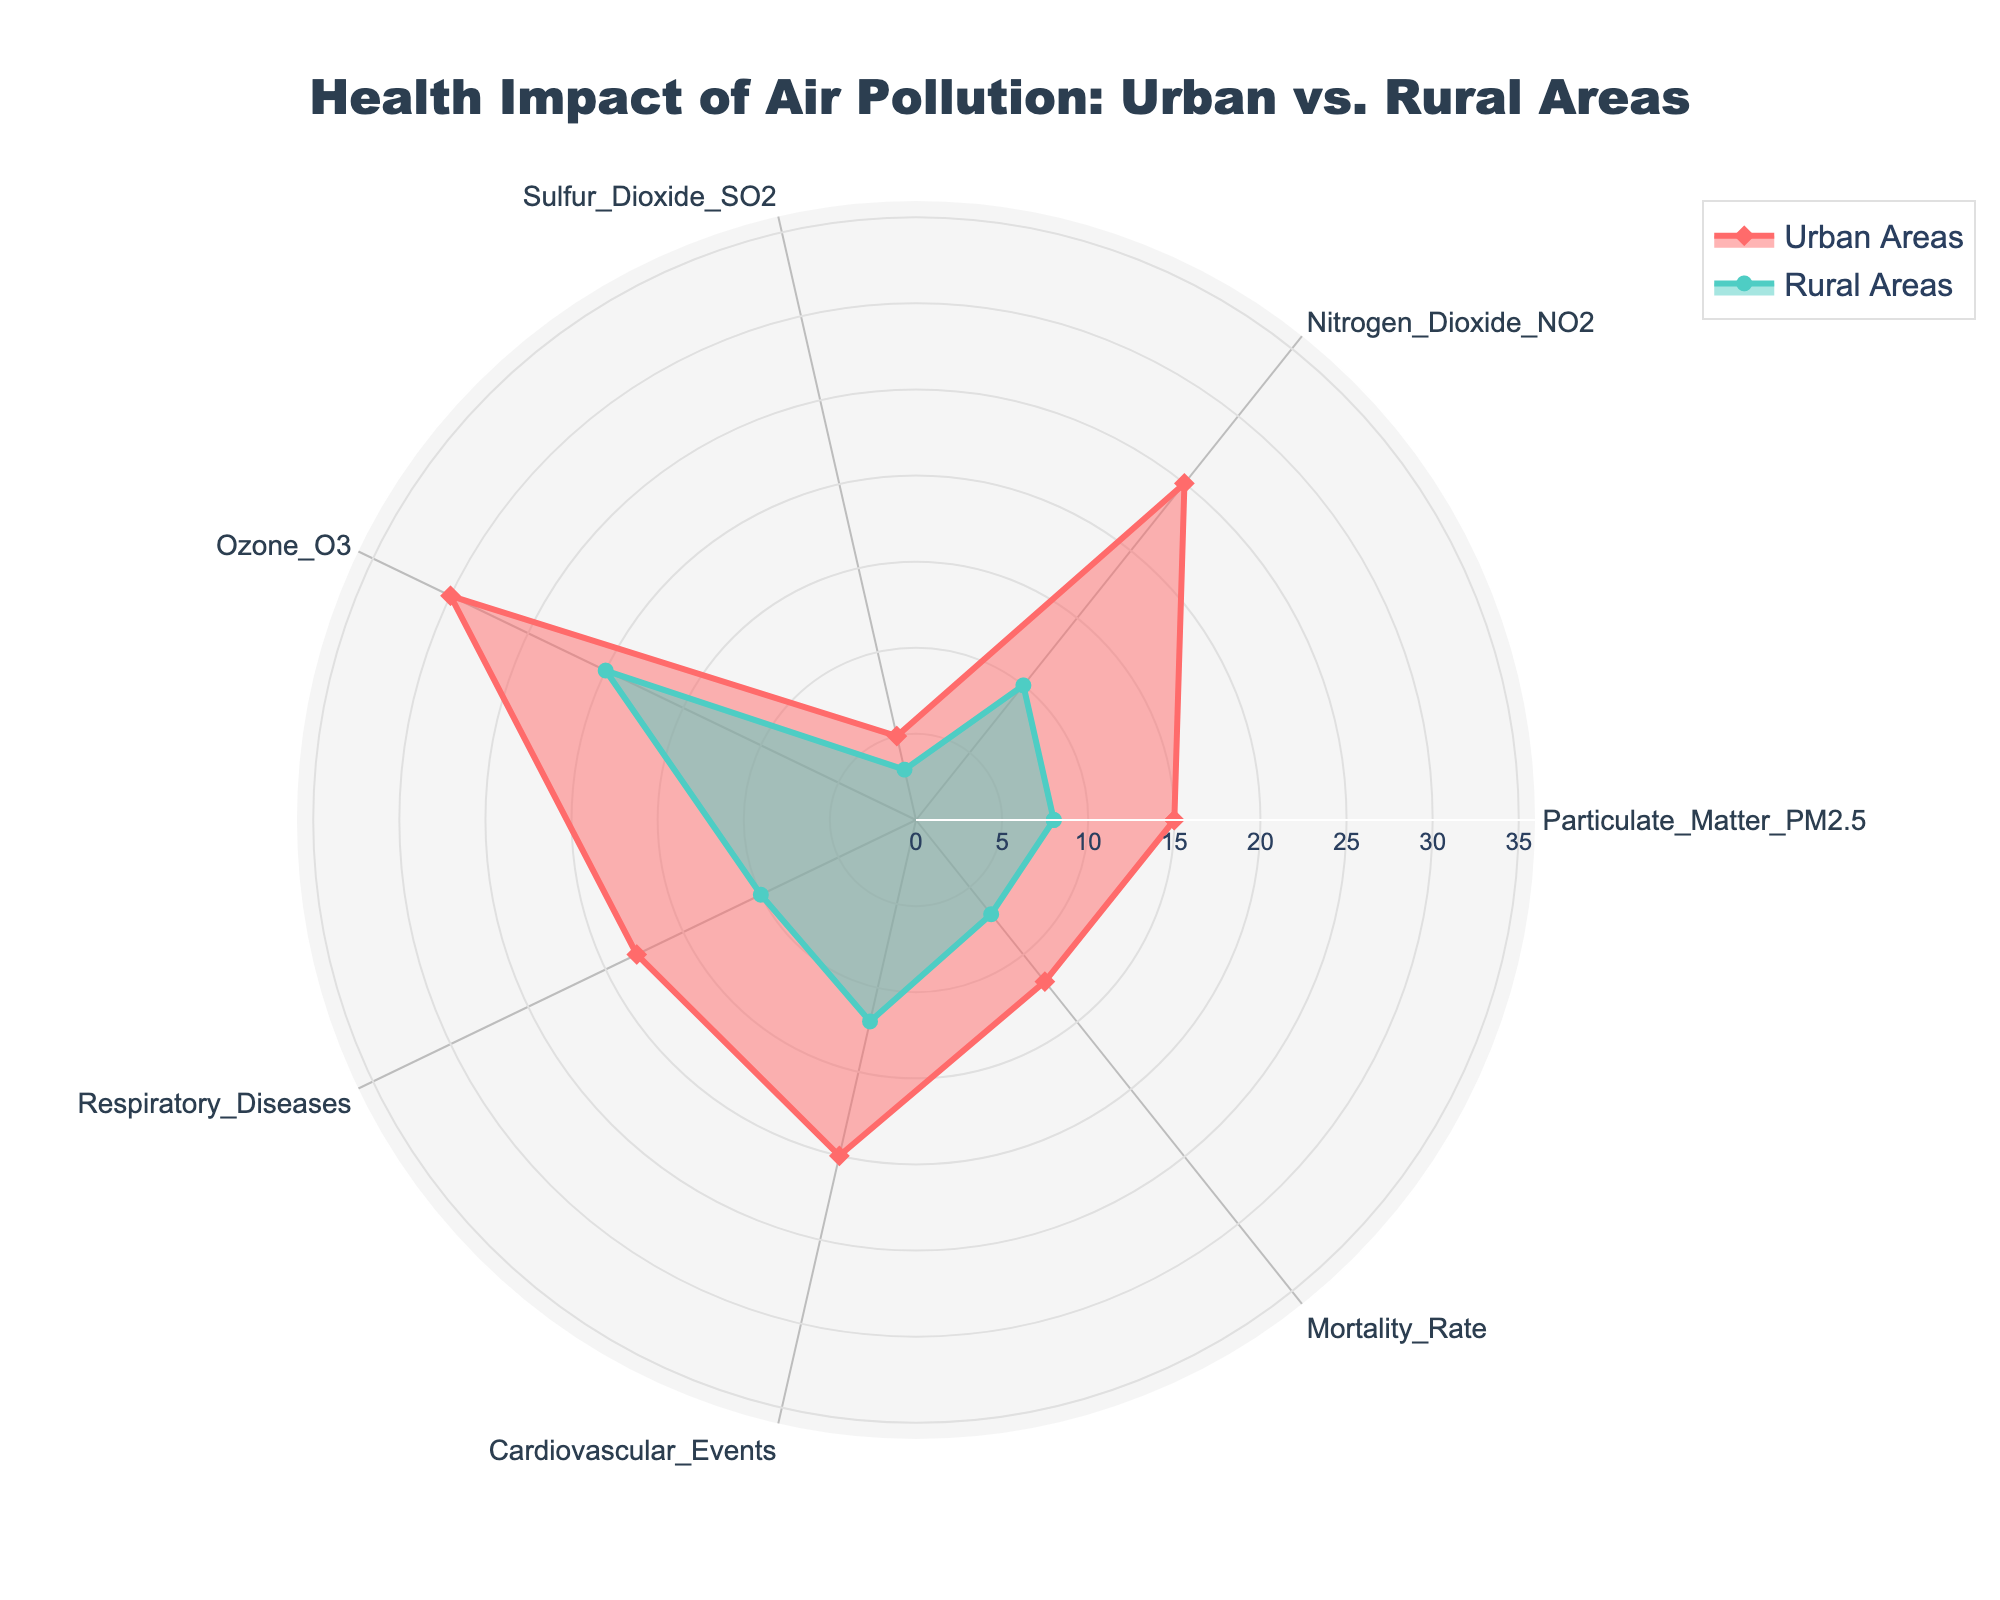What is the title of the radar chart? The title is centrally positioned at the top and is meant to provide an overview of the chart's data. From the given scenario, the title of the chart is "Health Impact of Air Pollution: Urban vs. Rural Areas."
Answer: Health Impact of Air Pollution: Urban vs. Rural Areas Which area has a higher concentration of Nitrogen Dioxide (NO2), urban or rural? Look for Nitrogen Dioxide (NO2) on the radar chart and compare the values for Urban Areas and Rural Areas. The Urban Areas line extends further out, indicating a higher concentration compared to Rural Areas.
Answer: Urban What is the range of values used for the radial axis? The radial axis range is chosen to accommodate the highest value on the chart. The highest value here is Ozone in Urban Areas, which is 30. The range is set slightly above 30 to ensure all data points fit within the chart.
Answer: Up to 36 What is the difference in the mortality rate between urban and rural areas? To find the difference, subtract the rural value of 7 from the urban value of 12 for the Mortality Rate category.
Answer: 5 Which pollutant shows the greatest disparity between urban and rural areas? Compare the urban and rural values for each pollutant. The pollutant with the largest difference in value is Nitrogen Dioxide (NO2) with Urban Areas at 25 and Rural Areas at 10, resulting in a disparity of 15.
Answer: Nitrogen Dioxide (NO2) What are the two health impacts listed in the chart? The categories labeled under health impacts, rather than pollutants, are "Respiratory Diseases" and "Cardiovascular Events." These can be identified by their positions on the chart.
Answer: Respiratory Diseases, Cardiovascular Events What is the total value of pollutants in urban areas? Add the urban values for Particulate Matter (15), Nitrogen Dioxide (25), Sulfur Dioxide (5), and Ozone (30). The total is 15 + 25 + 5 + 30.
Answer: 75 Which category is more severe in urban areas compared to rural areas? Examine all categories on the radar chart and identify those where urban values are consistently higher. All categories show higher severity in urban areas, but the most severe comparisons are visible in Nitrogen Dioxide (NO2) and Ozone (O3).
Answer: Nitrogen Dioxide (NO2) and Ozone (O3) How much higher is the Urban Areas value for Cardiovascular Events compared to Rural Areas? Subtract the Rural Areas value for Cardiovascular Events (12) from the Urban Areas value (20).
Answer: 8 